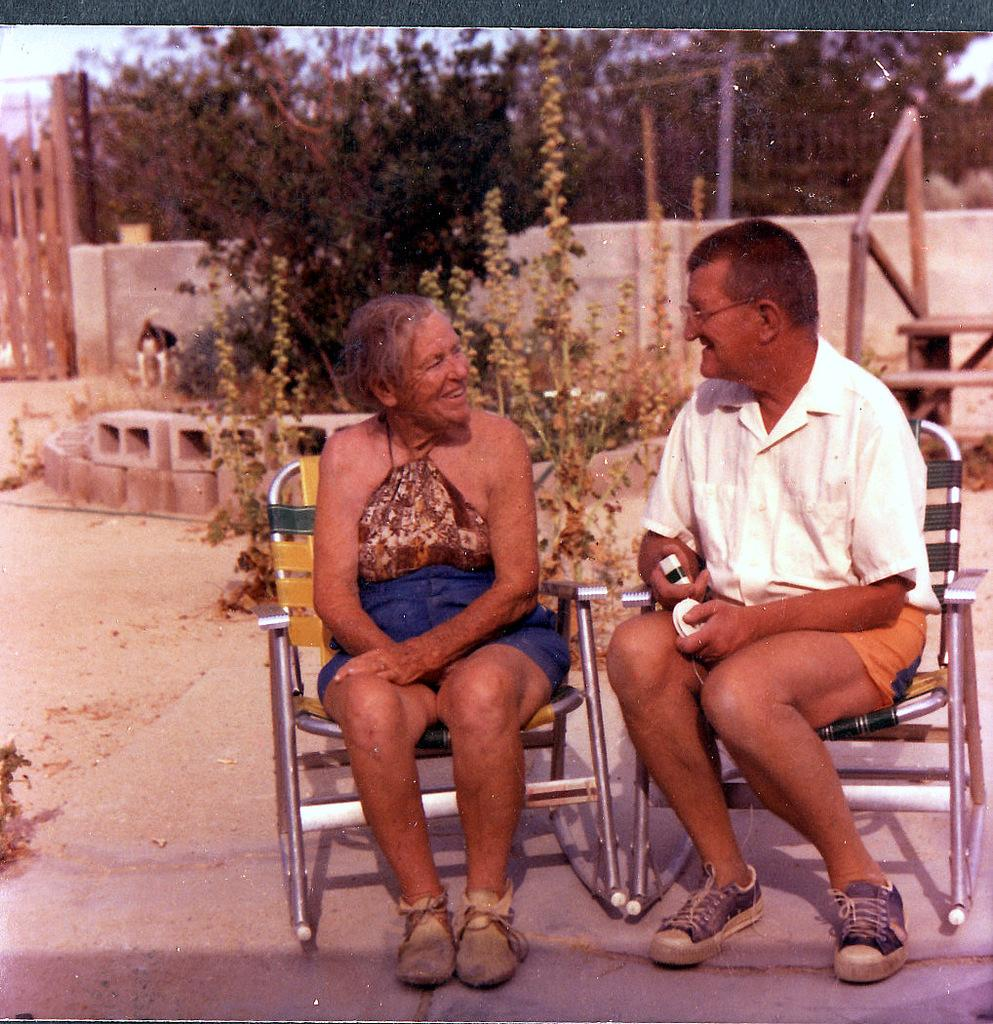How many people are in the image? There are two people in the image. What are the people doing in the image? The people are sitting on chairs. What can be observed about the people's clothing? The people are wearing different color dresses. What can be seen in the background of the image? There are many trees, a wall, and the sky visible in the background. How many geese are present in the image? There are no geese present in the image. What decision is the kitten making in the image? There is no kitten present in the image, so no decision can be made. 